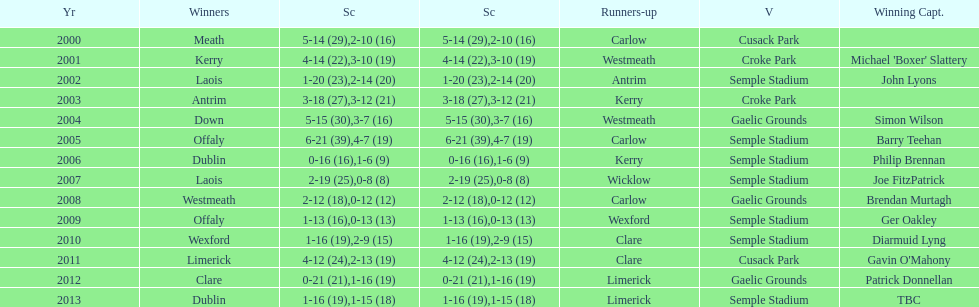Which team was the previous winner before dublin in 2013? Clare. 